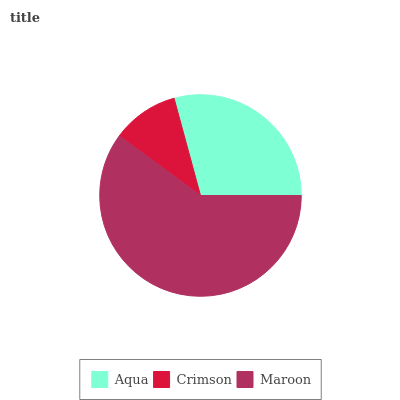Is Crimson the minimum?
Answer yes or no. Yes. Is Maroon the maximum?
Answer yes or no. Yes. Is Maroon the minimum?
Answer yes or no. No. Is Crimson the maximum?
Answer yes or no. No. Is Maroon greater than Crimson?
Answer yes or no. Yes. Is Crimson less than Maroon?
Answer yes or no. Yes. Is Crimson greater than Maroon?
Answer yes or no. No. Is Maroon less than Crimson?
Answer yes or no. No. Is Aqua the high median?
Answer yes or no. Yes. Is Aqua the low median?
Answer yes or no. Yes. Is Crimson the high median?
Answer yes or no. No. Is Maroon the low median?
Answer yes or no. No. 